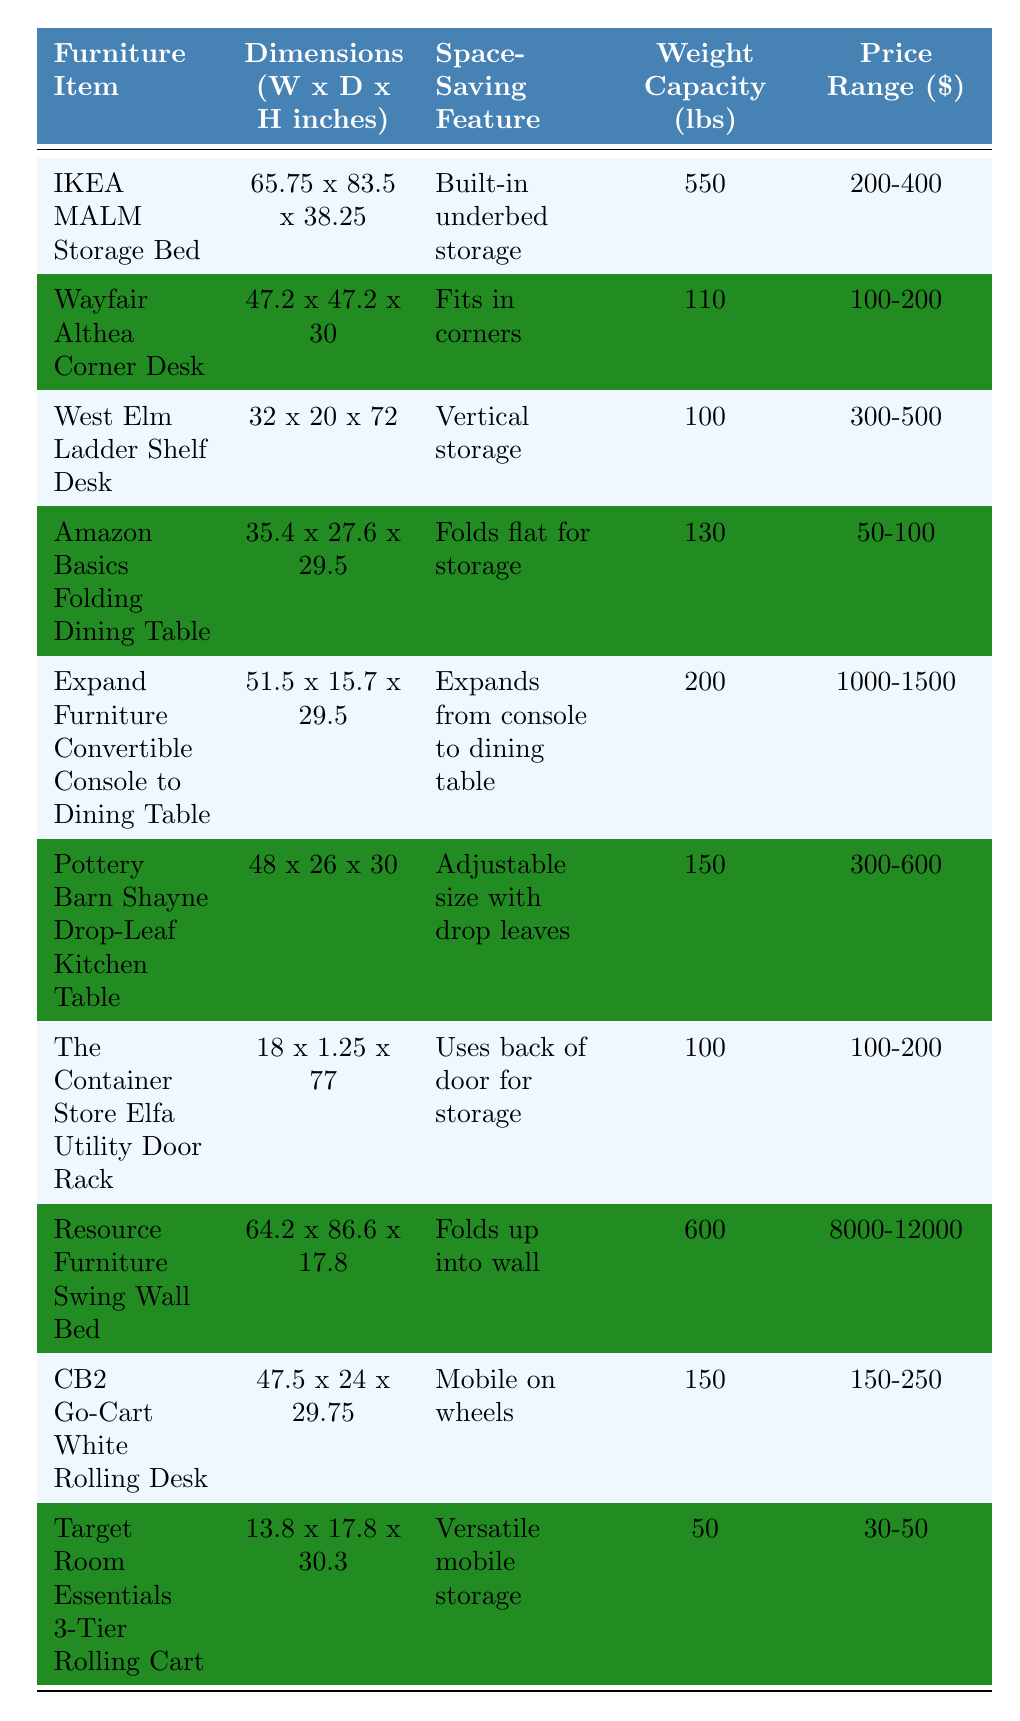What is the weight capacity of the IKEA MALM Storage Bed? The weight capacity is listed in the table next to the IKEA MALM Storage Bed entry. It is 550 lbs.
Answer: 550 lbs Which furniture item has the smallest dimensions? To find the smallest dimensions, we compare the width and depth of all items. The Target Room Essentials 3-Tier Rolling Cart has dimensions of 13.8 x 17.8 inches, which are smaller than any other item.
Answer: Target Room Essentials 3-Tier Rolling Cart How many furniture items have a price range below $300? We examine the price ranges listed for each item in the table. The following five items have price ranges below $300: Amazon Basics Folding Dining Table, Expand Furniture Convertible Console to Dining Table, Pottery Barn Shayne Drop-Leaf Kitchen Table, The Container Store Elfa Utility Door Rack, and Target Room Essentials 3-Tier Rolling Cart. Therefore, there are 5 items total.
Answer: 5 What is the difference between the maximum and minimum weight capacities listed? The maximum weight capacity is 8000 lbs (Resource Furniture Swing Wall Bed) and the minimum is 30 lbs (Target Room Essentials 3-Tier Rolling Cart). The difference is calculated as 8000 - 30 = 7970 lbs.
Answer: 7970 lbs Does any furniture item have a space-saving feature of "fits in corners"? We can look through the space-saving features listed in the table. The Wayfair Althea Corner Desk has the feature "Fits in corners," so this statement is true.
Answer: Yes What is the total weight capacity of all items listed? We sum the weight capacities from the table: 550 + 110 + 100 + 130 + 200 + 150 + 100 + 600 + 150 + 50 = 2140 lbs.
Answer: 2140 lbs Are there any items in the table that can be used for mobile storage? We check the space-saving features for each item. Two items, the CB2 Go-Cart White Rolling Desk and the Target Room Essentials 3-Tier Rolling Cart, indicate that they are mobile storage.
Answer: Yes Which item is the most expensive, and what is its price range? We look for the highest price range in the table. The Resource Furniture Swing Wall Bed has the highest price range listed at $8000-12000.
Answer: Resource Furniture Swing Wall Bed, $8000-12000 What is the average price range of the furniture items with foldable features? The items with foldable features are the Amazon Basics Folding Dining Table and the Expand Furniture Convertible Console to Dining Table. Their respective price ranges are $50-100 and $1000-1500. To find the average, we take the midpoint of each range, (50+100)/2 = 75 and (1000+1500)/2 = 1250, then average these two values: (75 + 1250) / 2 = 662.5.
Answer: $662.5 How many items can hold a weight capacity of at least 150 lbs? We review the weight capacities in the table. The following items can hold at least 150 lbs: IKEA MALM Storage Bed, Pottery Barn Shayne Drop-Leaf Kitchen Table, Resource Furniture Swing Wall Bed, CB2 Go-Cart White Rolling Desk. This gives us a total of 4 items.
Answer: 4 